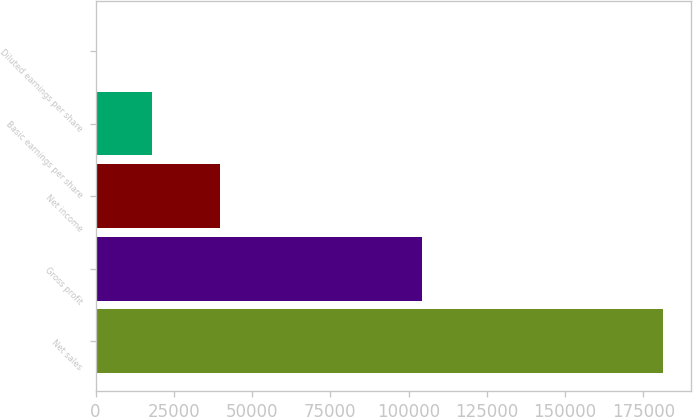Convert chart. <chart><loc_0><loc_0><loc_500><loc_500><bar_chart><fcel>Net sales<fcel>Gross profit<fcel>Net income<fcel>Basic earnings per share<fcel>Diluted earnings per share<nl><fcel>181276<fcel>104288<fcel>39599<fcel>18128.3<fcel>0.78<nl></chart> 